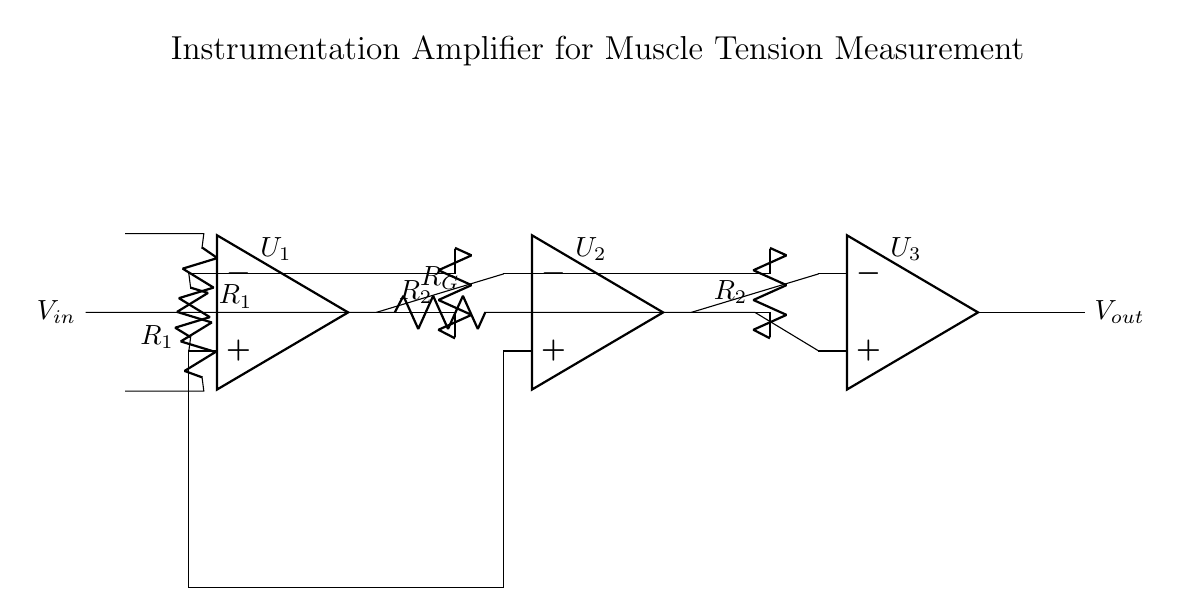What type of circuit is shown? The circuit depicted is an instrumentation amplifier, which is designed for precise low-level signal amplification. It's characterized by multiple operational amplifiers used for amplifying the difference between two input signals while rejecting common-mode noise.
Answer: instrumentation amplifier How many operational amplifiers are in the circuit? There are three operational amplifiers represented in the diagram, which are labeled as U1, U2, and U3. Instrumentation amplifiers typically use three op-amps for improved accuracy and stability.
Answer: three What is the role of the resistors labeled R1? The resistors labeled R1 serve as input resistors that establish the gain and set the input impedance for the amplifier. By having equal values, they help to maintain balance in the circuit.
Answer: input resistors What is the purpose of R2 in this circuit? R2 serves as a feedback resistor which influences the gain of the amplifier stages. The value of R2, along with other components, helps determine the overall amplification factor of the instrumentation amplifier.
Answer: feedback resistor Which component is responsible for the output voltage? The output voltage is taken from the third operational amplifier (U3), which is designed to amplify the difference between the signals processed by the previous amplifiers, resulting in the final output signal.
Answer: U3 How can the gain of this amplifier be adjusted? The gain can be adjusted by changing the values of the resistors R1 and R2. Alternatively, the resistor labeled R_G can be modified to fine-tune the gain, depending on the specific application requirements.
Answer: R_G What is the significance of the connection between U1 and U2? The connection between U1 and U2 allows for differential signal processing; U1 amplifies the input signals and provides a differential output that U2 further processes to increase gain while rejecting common-mode signals.
Answer: differential signal processing 